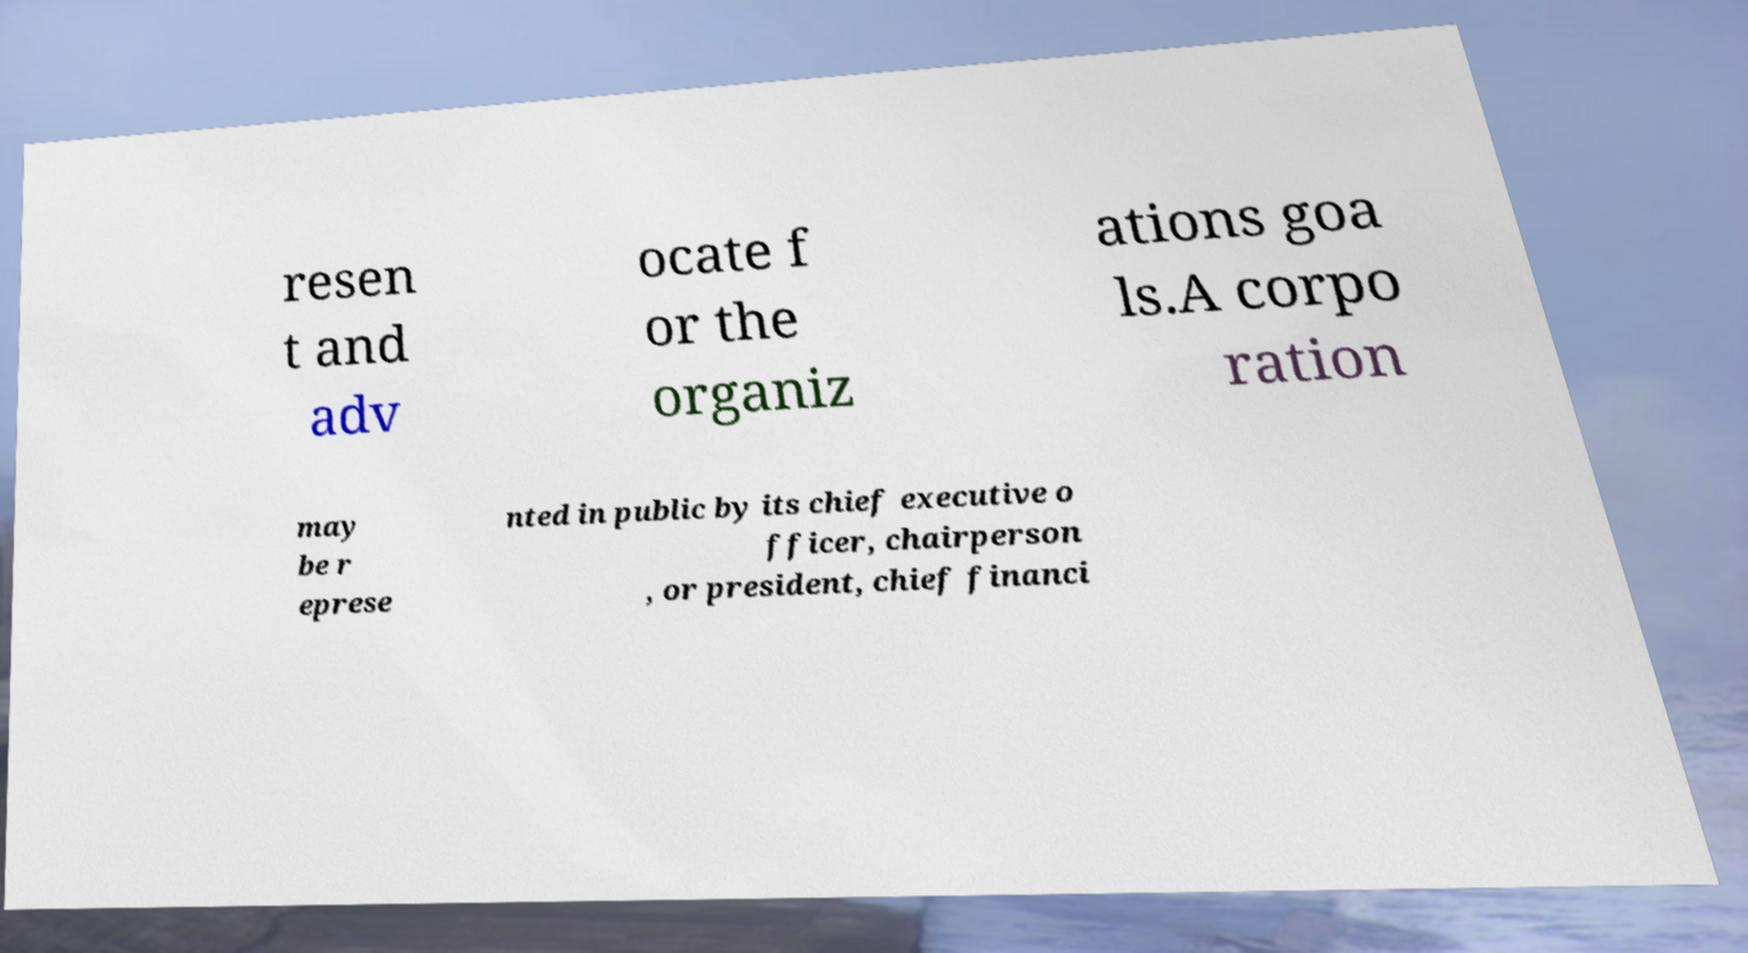There's text embedded in this image that I need extracted. Can you transcribe it verbatim? resen t and adv ocate f or the organiz ations goa ls.A corpo ration may be r eprese nted in public by its chief executive o fficer, chairperson , or president, chief financi 